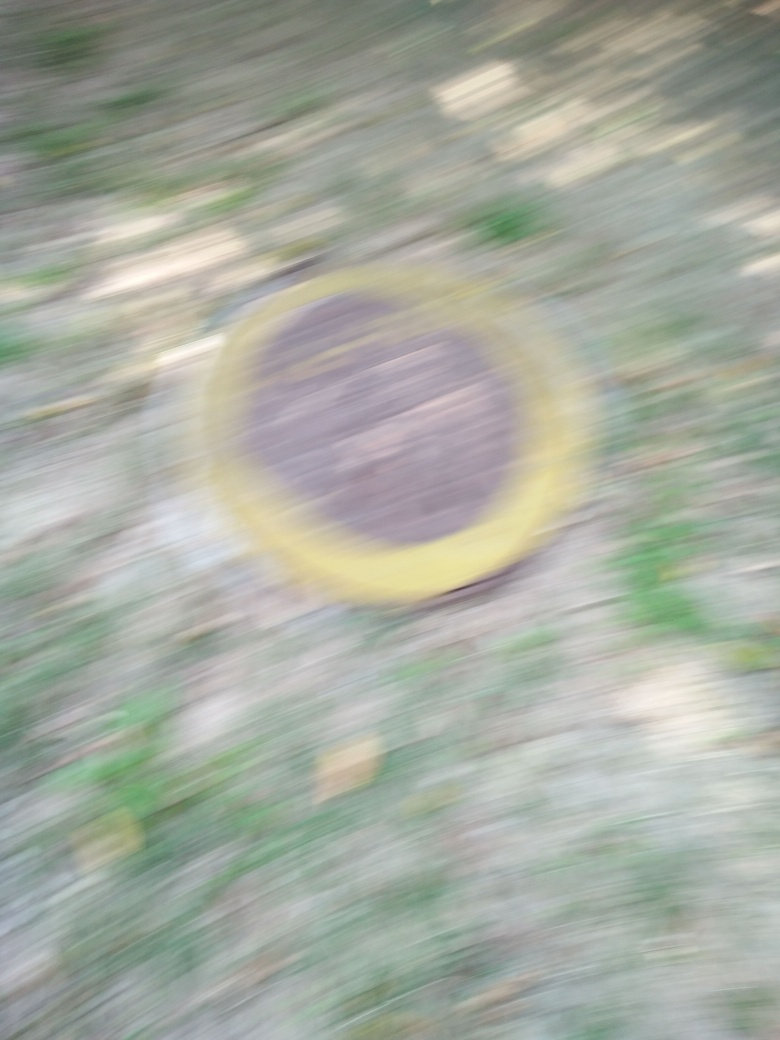What happened to the texture details of the circular subject? The texture details of the circular subject are not discernible due to the motion blur effect present in the image. It appears that the camera was moving during the exposure, resulting in a smeared visual representation where fine details cannot be clearly observed. 